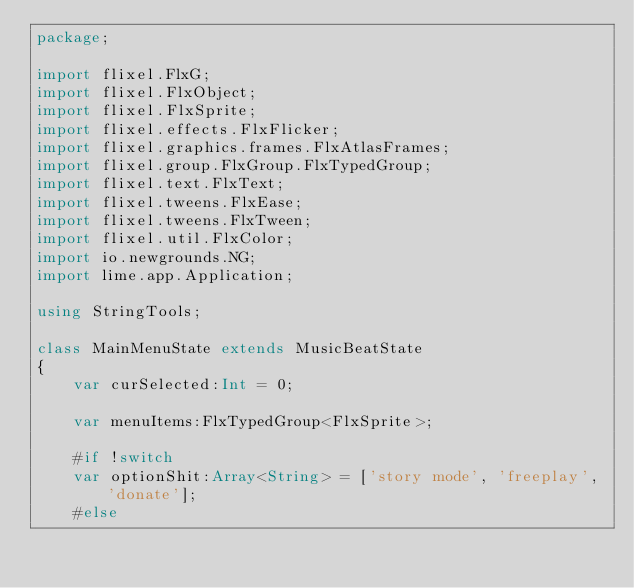Convert code to text. <code><loc_0><loc_0><loc_500><loc_500><_Haxe_>package;

import flixel.FlxG;
import flixel.FlxObject;
import flixel.FlxSprite;
import flixel.effects.FlxFlicker;
import flixel.graphics.frames.FlxAtlasFrames;
import flixel.group.FlxGroup.FlxTypedGroup;
import flixel.text.FlxText;
import flixel.tweens.FlxEase;
import flixel.tweens.FlxTween;
import flixel.util.FlxColor;
import io.newgrounds.NG;
import lime.app.Application;

using StringTools;

class MainMenuState extends MusicBeatState
{
	var curSelected:Int = 0;

	var menuItems:FlxTypedGroup<FlxSprite>;

	#if !switch
	var optionShit:Array<String> = ['story mode', 'freeplay', 'donate'];
	#else</code> 